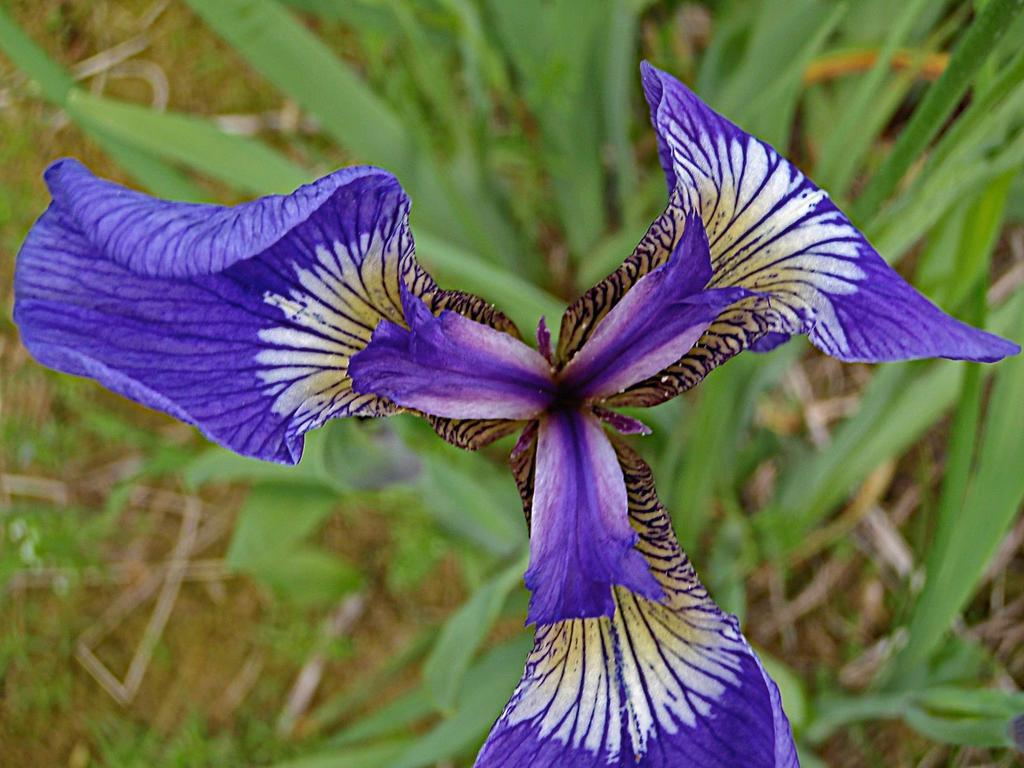What type of living organisms can be seen in the image? There are flowers in the image. What colors are present in the flowers? The flowers have purple, cream, and brown colors. What can be seen in the background of the image? The background of the image includes plants with green color. What type of worm can be seen crawling on the dad's boat in the image? There is no worm or dad's boat present in the image; it features flowers and plants. 